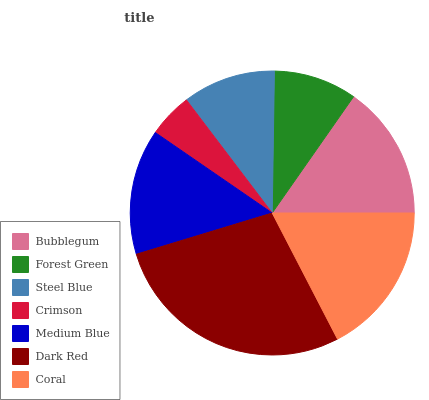Is Crimson the minimum?
Answer yes or no. Yes. Is Dark Red the maximum?
Answer yes or no. Yes. Is Forest Green the minimum?
Answer yes or no. No. Is Forest Green the maximum?
Answer yes or no. No. Is Bubblegum greater than Forest Green?
Answer yes or no. Yes. Is Forest Green less than Bubblegum?
Answer yes or no. Yes. Is Forest Green greater than Bubblegum?
Answer yes or no. No. Is Bubblegum less than Forest Green?
Answer yes or no. No. Is Medium Blue the high median?
Answer yes or no. Yes. Is Medium Blue the low median?
Answer yes or no. Yes. Is Coral the high median?
Answer yes or no. No. Is Coral the low median?
Answer yes or no. No. 